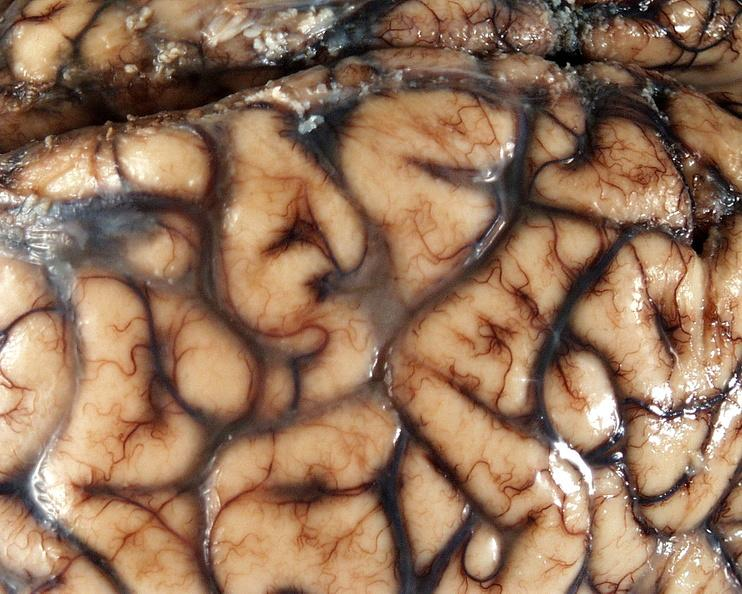what is present?
Answer the question using a single word or phrase. Nervous 